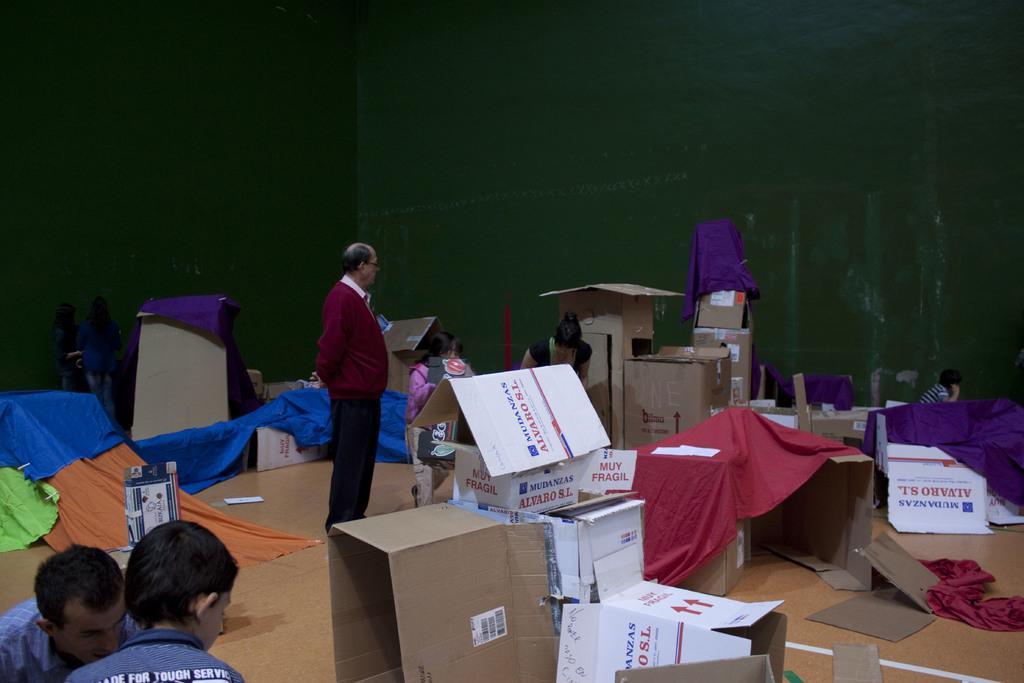Can you describe this image briefly? In this image in the center there is one person who is standing and there are some people in the background who are working. At the bottom there are two persons and on the floor we could see some boxes, clothes, papers, and in the background there is a wall. 